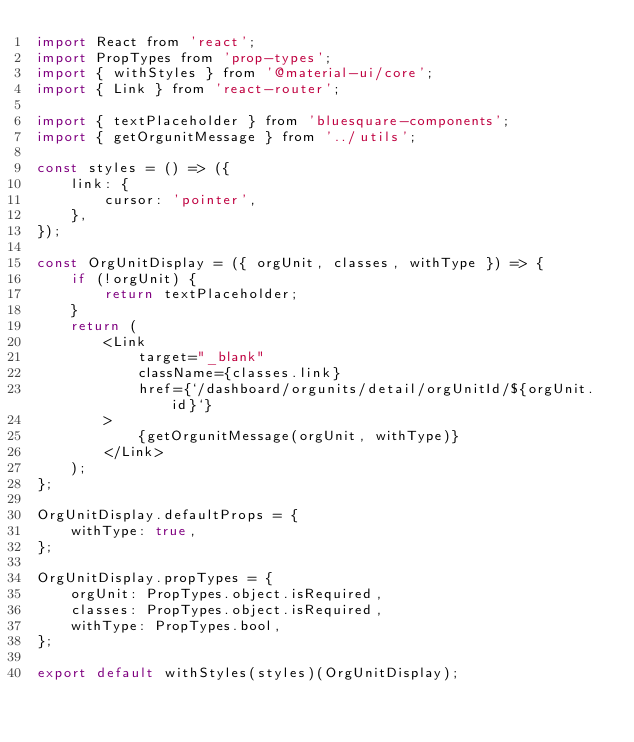<code> <loc_0><loc_0><loc_500><loc_500><_JavaScript_>import React from 'react';
import PropTypes from 'prop-types';
import { withStyles } from '@material-ui/core';
import { Link } from 'react-router';

import { textPlaceholder } from 'bluesquare-components';
import { getOrgunitMessage } from '../utils';

const styles = () => ({
    link: {
        cursor: 'pointer',
    },
});

const OrgUnitDisplay = ({ orgUnit, classes, withType }) => {
    if (!orgUnit) {
        return textPlaceholder;
    }
    return (
        <Link
            target="_blank"
            className={classes.link}
            href={`/dashboard/orgunits/detail/orgUnitId/${orgUnit.id}`}
        >
            {getOrgunitMessage(orgUnit, withType)}
        </Link>
    );
};

OrgUnitDisplay.defaultProps = {
    withType: true,
};

OrgUnitDisplay.propTypes = {
    orgUnit: PropTypes.object.isRequired,
    classes: PropTypes.object.isRequired,
    withType: PropTypes.bool,
};

export default withStyles(styles)(OrgUnitDisplay);
</code> 